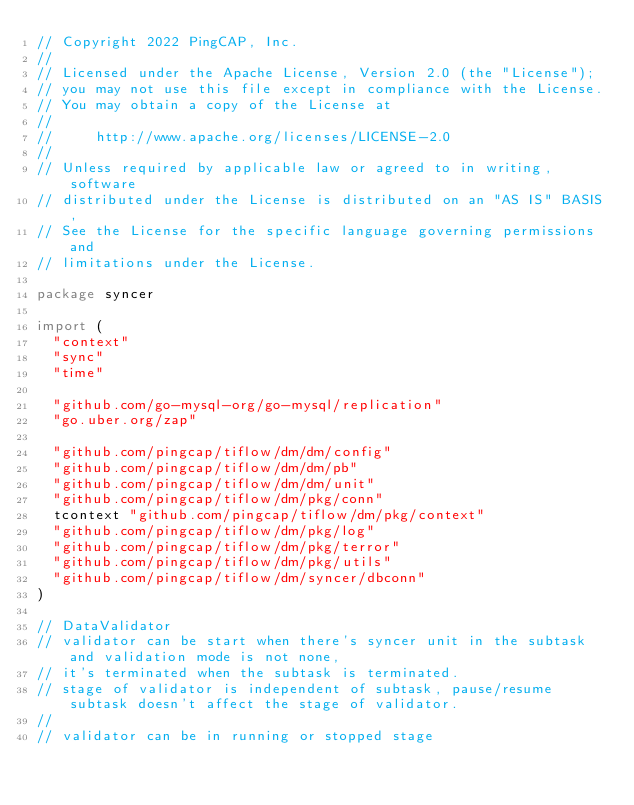<code> <loc_0><loc_0><loc_500><loc_500><_Go_>// Copyright 2022 PingCAP, Inc.
//
// Licensed under the Apache License, Version 2.0 (the "License");
// you may not use this file except in compliance with the License.
// You may obtain a copy of the License at
//
//     http://www.apache.org/licenses/LICENSE-2.0
//
// Unless required by applicable law or agreed to in writing, software
// distributed under the License is distributed on an "AS IS" BASIS,
// See the License for the specific language governing permissions and
// limitations under the License.

package syncer

import (
	"context"
	"sync"
	"time"

	"github.com/go-mysql-org/go-mysql/replication"
	"go.uber.org/zap"

	"github.com/pingcap/tiflow/dm/dm/config"
	"github.com/pingcap/tiflow/dm/dm/pb"
	"github.com/pingcap/tiflow/dm/dm/unit"
	"github.com/pingcap/tiflow/dm/pkg/conn"
	tcontext "github.com/pingcap/tiflow/dm/pkg/context"
	"github.com/pingcap/tiflow/dm/pkg/log"
	"github.com/pingcap/tiflow/dm/pkg/terror"
	"github.com/pingcap/tiflow/dm/pkg/utils"
	"github.com/pingcap/tiflow/dm/syncer/dbconn"
)

// DataValidator
// validator can be start when there's syncer unit in the subtask and validation mode is not none,
// it's terminated when the subtask is terminated.
// stage of validator is independent of subtask, pause/resume subtask doesn't affect the stage of validator.
//
// validator can be in running or stopped stage</code> 